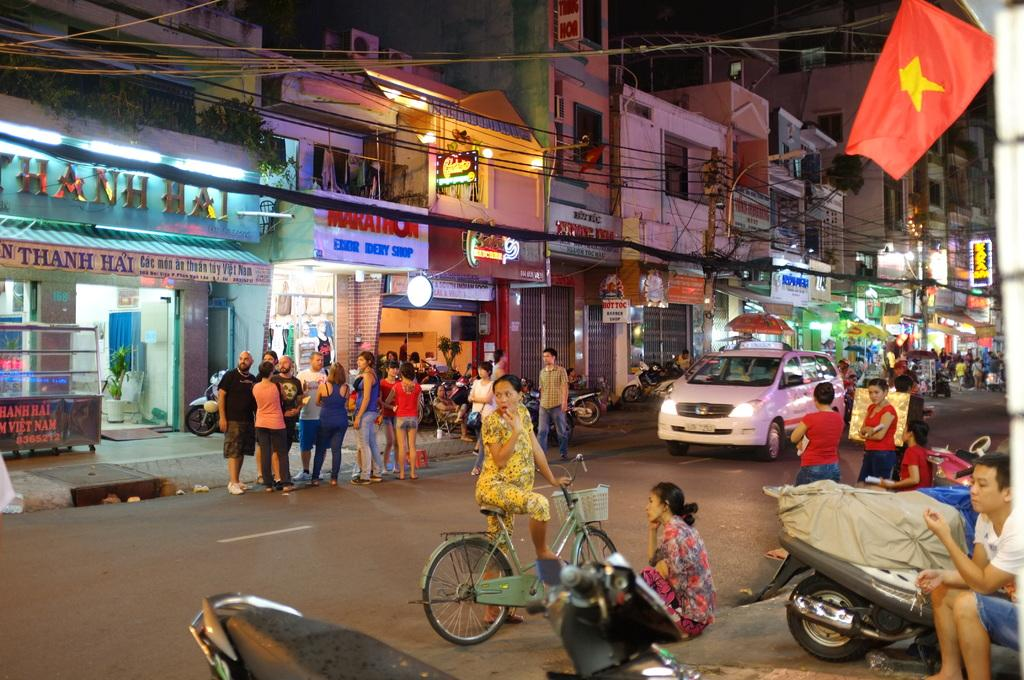<image>
Relay a brief, clear account of the picture shown. Thanh Hai is the first business showing on this crowded city street. 